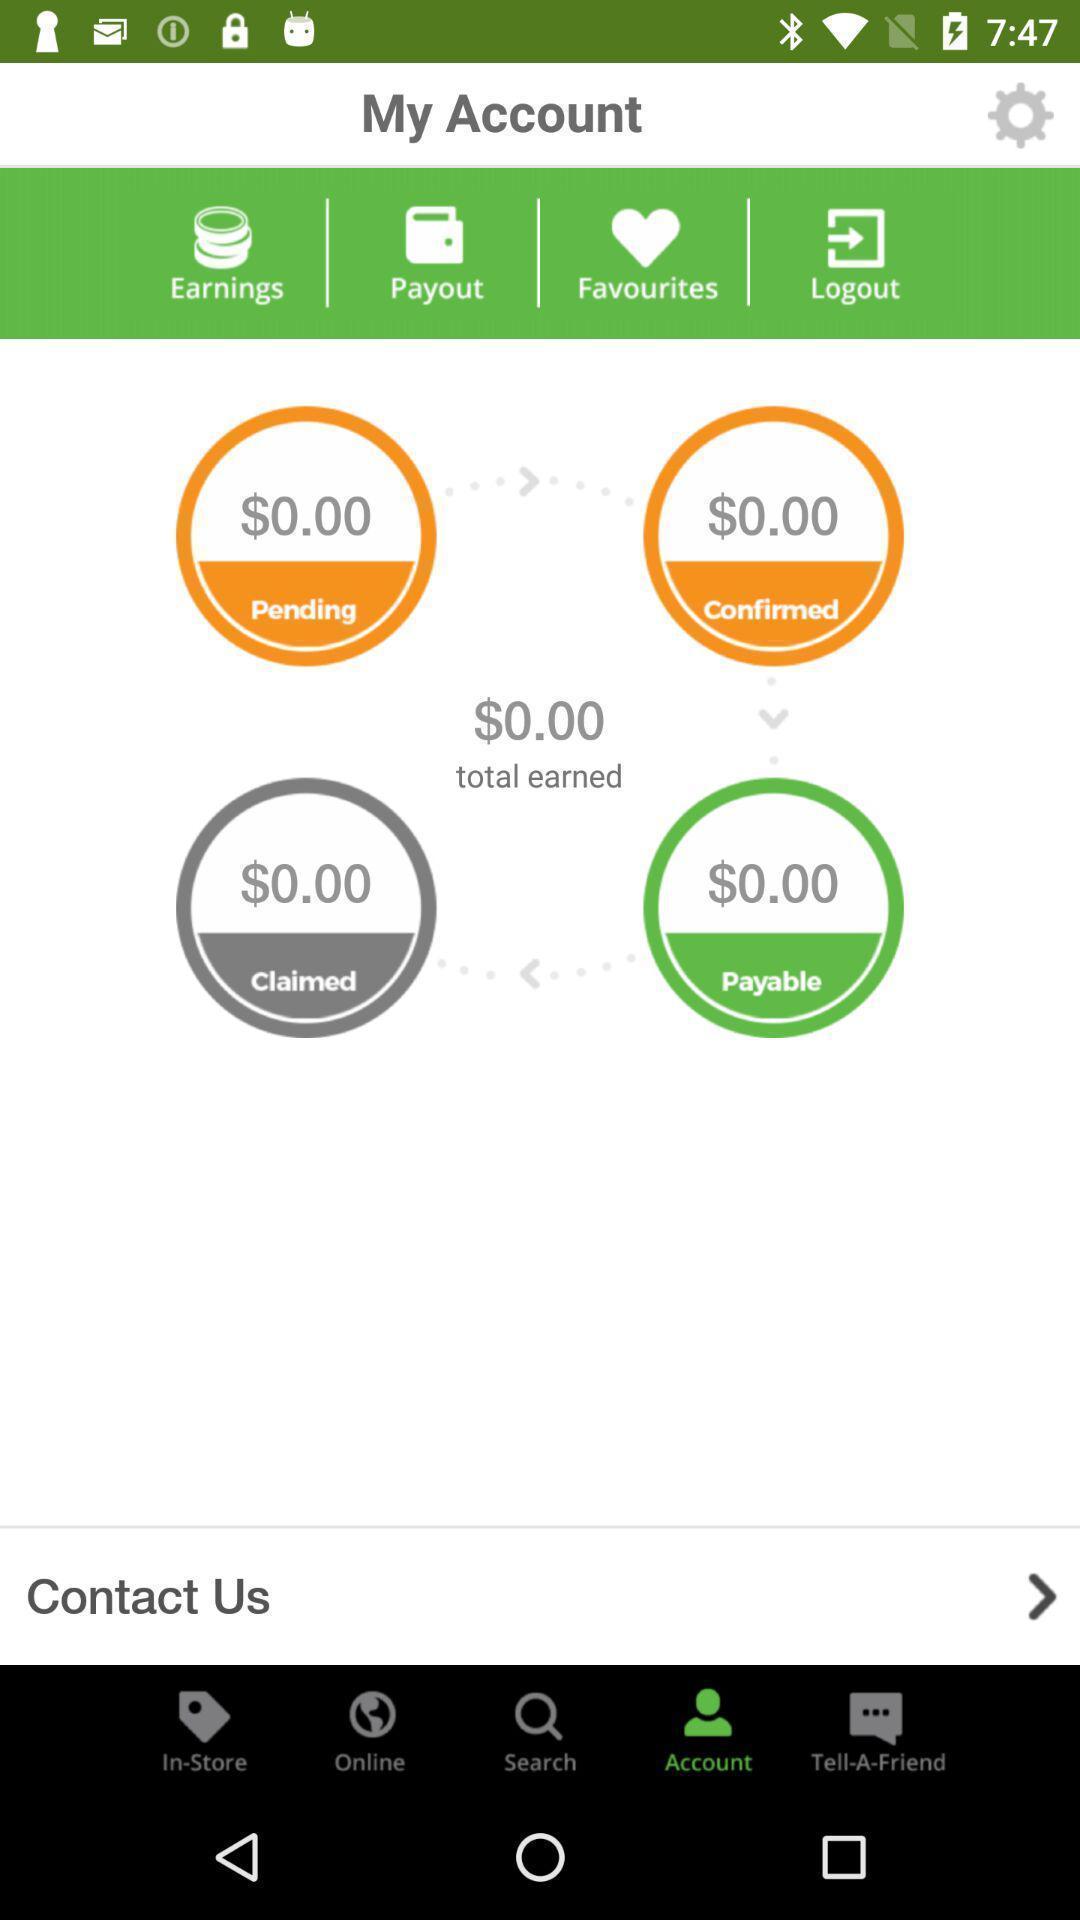Give me a narrative description of this picture. Screen shows my account page in cashback application. 